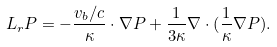Convert formula to latex. <formula><loc_0><loc_0><loc_500><loc_500>L _ { r } P = - \frac { { v _ { b } } / c } { \kappa } \cdot \nabla P + \frac { 1 } { 3 \kappa } \nabla \cdot ( \frac { 1 } { \kappa } \nabla P ) .</formula> 